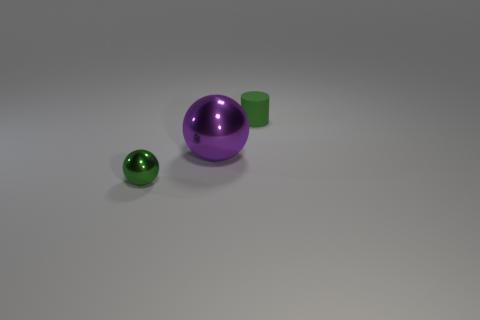Add 1 tiny things. How many objects exist? 4 Subtract all balls. How many objects are left? 1 Subtract all tiny brown metallic cylinders. Subtract all matte things. How many objects are left? 2 Add 1 big metal balls. How many big metal balls are left? 2 Add 3 small cylinders. How many small cylinders exist? 4 Subtract 0 red balls. How many objects are left? 3 